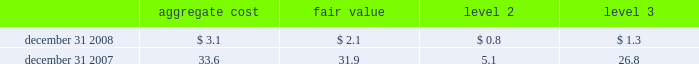- the increase in level 3 short-term borrowings and long-term debt of $ 2.8 billion and $ 7.3 billion , respectively , resulted from transfers in of level 2 positions as prices and other valuation inputs became unobservable , plus the additions of new issuances for fair value accounting was elected .
Items measured at fair value on a nonrecurring basis certain assets and liabilities are measured at fair value on a nonrecurring basis and therefore are not included in the tables above .
These include assets measured at cost that have been written down to fair value during the periods as a result of an impairment .
In addition , assets such as loans held for sale that are measured at the lower of cost or market ( locom ) that were recognized at fair value below cost at the end of the period .
The company recorded goodwill impairment charges of $ 9.6 billion as of december 31 , 2008 , as determined based on level 3 inputs .
The primary cause of goodwill impairment was the overall weak industry outlook and continuing operating losses .
These factors contributed to the overall decline in the stock price and the related market capitalization of citigroup .
See note 19 , 201cgoodwill and intangible assets 201d on page 166 , for additional information on goodwill impairment .
The company performed an impairment analysis of intangible assets related to the old lane multi-strategy hedge fund during the first quarter of 2008 .
As a result , a pre-tax write-down of $ 202 million , representing the remaining unamortized balance of the intangible assets , was recorded during the first quarter of 2008 .
The measurement of fair value was determined using level 3 input factors along with a discounted cash flow approach .
During the fourth quarter of 2008 , the company performed an impairment analysis of japan's nikko asset management fund contracts which represent the rights to manage and collect fees on investor assets and are accounted for as indefinite-lived intangible assets .
As a result , an impairment loss of $ 937 million pre-tax was recorded .
The related fair value was determined using an income approach which relies on key drivers and future expectations of the business that are considered level 3 input factors .
The fair value of loans measured on a locom basis is determined where possible using quoted secondary-market prices .
Such loans are generally classified in level 2 of the fair-value hierarchy given the level of activity in the market and the frequency of available quotes .
If no such quoted price exists , the fair value of a loan is determined using quoted prices for a similar asset or assets , adjusted for the specific attributes of that loan .
The table presents all loans held-for-sale that are carried at locom as of december 31 , 2008 and december 31 , 2007 ( in billions ) : .
Loans held-for-sale that are carried at locom as of december 31 , 2008 significantly declined compared to december 31 , 2007 because most of these loans were either sold or reclassified to held-for-investment category. .
At december 312008 what was the difference between the aggregate and the fair value of the loans held-for-sale that are carried at locom in billions? 
Rationale: at december 312008 there was a difference of $ 1 billion between the aggregate and the fair value of the loans held-for-sale
Computations: (3.1 - 2.1)
Answer: 1.0. 